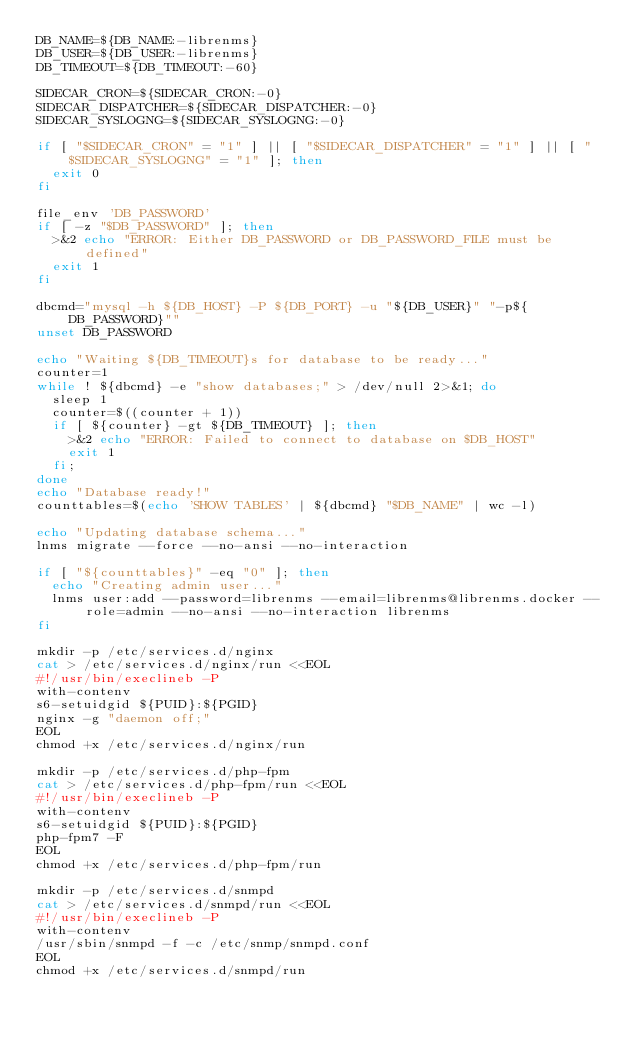<code> <loc_0><loc_0><loc_500><loc_500><_Bash_>DB_NAME=${DB_NAME:-librenms}
DB_USER=${DB_USER:-librenms}
DB_TIMEOUT=${DB_TIMEOUT:-60}

SIDECAR_CRON=${SIDECAR_CRON:-0}
SIDECAR_DISPATCHER=${SIDECAR_DISPATCHER:-0}
SIDECAR_SYSLOGNG=${SIDECAR_SYSLOGNG:-0}

if [ "$SIDECAR_CRON" = "1" ] || [ "$SIDECAR_DISPATCHER" = "1" ] || [ "$SIDECAR_SYSLOGNG" = "1" ]; then
  exit 0
fi

file_env 'DB_PASSWORD'
if [ -z "$DB_PASSWORD" ]; then
  >&2 echo "ERROR: Either DB_PASSWORD or DB_PASSWORD_FILE must be defined"
  exit 1
fi

dbcmd="mysql -h ${DB_HOST} -P ${DB_PORT} -u "${DB_USER}" "-p${DB_PASSWORD}""
unset DB_PASSWORD

echo "Waiting ${DB_TIMEOUT}s for database to be ready..."
counter=1
while ! ${dbcmd} -e "show databases;" > /dev/null 2>&1; do
  sleep 1
  counter=$((counter + 1))
  if [ ${counter} -gt ${DB_TIMEOUT} ]; then
    >&2 echo "ERROR: Failed to connect to database on $DB_HOST"
    exit 1
  fi;
done
echo "Database ready!"
counttables=$(echo 'SHOW TABLES' | ${dbcmd} "$DB_NAME" | wc -l)

echo "Updating database schema..."
lnms migrate --force --no-ansi --no-interaction

if [ "${counttables}" -eq "0" ]; then
  echo "Creating admin user..."
  lnms user:add --password=librenms --email=librenms@librenms.docker --role=admin --no-ansi --no-interaction librenms
fi

mkdir -p /etc/services.d/nginx
cat > /etc/services.d/nginx/run <<EOL
#!/usr/bin/execlineb -P
with-contenv
s6-setuidgid ${PUID}:${PGID}
nginx -g "daemon off;"
EOL
chmod +x /etc/services.d/nginx/run

mkdir -p /etc/services.d/php-fpm
cat > /etc/services.d/php-fpm/run <<EOL
#!/usr/bin/execlineb -P
with-contenv
s6-setuidgid ${PUID}:${PGID}
php-fpm7 -F
EOL
chmod +x /etc/services.d/php-fpm/run

mkdir -p /etc/services.d/snmpd
cat > /etc/services.d/snmpd/run <<EOL
#!/usr/bin/execlineb -P
with-contenv
/usr/sbin/snmpd -f -c /etc/snmp/snmpd.conf
EOL
chmod +x /etc/services.d/snmpd/run
</code> 